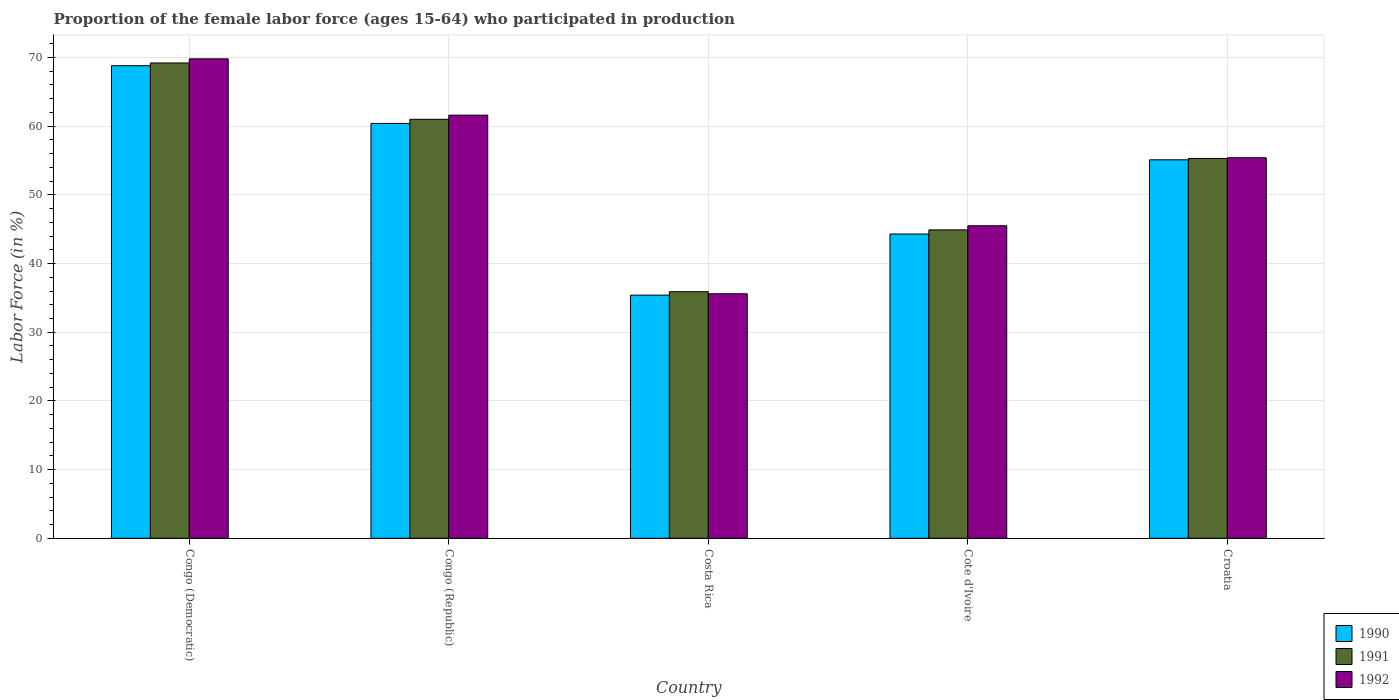How many different coloured bars are there?
Offer a terse response. 3. How many groups of bars are there?
Provide a succinct answer. 5. Are the number of bars on each tick of the X-axis equal?
Offer a very short reply. Yes. How many bars are there on the 3rd tick from the left?
Ensure brevity in your answer.  3. What is the label of the 3rd group of bars from the left?
Your answer should be compact. Costa Rica. In how many cases, is the number of bars for a given country not equal to the number of legend labels?
Your answer should be very brief. 0. What is the proportion of the female labor force who participated in production in 1991 in Costa Rica?
Offer a terse response. 35.9. Across all countries, what is the maximum proportion of the female labor force who participated in production in 1991?
Offer a very short reply. 69.2. Across all countries, what is the minimum proportion of the female labor force who participated in production in 1990?
Your answer should be compact. 35.4. In which country was the proportion of the female labor force who participated in production in 1992 maximum?
Make the answer very short. Congo (Democratic). In which country was the proportion of the female labor force who participated in production in 1991 minimum?
Ensure brevity in your answer.  Costa Rica. What is the total proportion of the female labor force who participated in production in 1992 in the graph?
Provide a succinct answer. 267.9. What is the difference between the proportion of the female labor force who participated in production in 1990 in Cote d'Ivoire and that in Croatia?
Give a very brief answer. -10.8. What is the average proportion of the female labor force who participated in production in 1992 per country?
Give a very brief answer. 53.58. What is the difference between the proportion of the female labor force who participated in production of/in 1991 and proportion of the female labor force who participated in production of/in 1990 in Croatia?
Give a very brief answer. 0.2. In how many countries, is the proportion of the female labor force who participated in production in 1990 greater than 62 %?
Your answer should be very brief. 1. What is the ratio of the proportion of the female labor force who participated in production in 1991 in Costa Rica to that in Cote d'Ivoire?
Your answer should be compact. 0.8. Is the proportion of the female labor force who participated in production in 1990 in Congo (Republic) less than that in Cote d'Ivoire?
Make the answer very short. No. Is the difference between the proportion of the female labor force who participated in production in 1991 in Costa Rica and Croatia greater than the difference between the proportion of the female labor force who participated in production in 1990 in Costa Rica and Croatia?
Keep it short and to the point. Yes. What is the difference between the highest and the second highest proportion of the female labor force who participated in production in 1990?
Your answer should be very brief. 8.4. What is the difference between the highest and the lowest proportion of the female labor force who participated in production in 1990?
Give a very brief answer. 33.4. In how many countries, is the proportion of the female labor force who participated in production in 1992 greater than the average proportion of the female labor force who participated in production in 1992 taken over all countries?
Provide a short and direct response. 3. Is the sum of the proportion of the female labor force who participated in production in 1990 in Congo (Republic) and Cote d'Ivoire greater than the maximum proportion of the female labor force who participated in production in 1991 across all countries?
Your response must be concise. Yes. What does the 2nd bar from the right in Congo (Republic) represents?
Make the answer very short. 1991. Is it the case that in every country, the sum of the proportion of the female labor force who participated in production in 1991 and proportion of the female labor force who participated in production in 1990 is greater than the proportion of the female labor force who participated in production in 1992?
Give a very brief answer. Yes. How many bars are there?
Provide a succinct answer. 15. How many countries are there in the graph?
Your answer should be very brief. 5. Are the values on the major ticks of Y-axis written in scientific E-notation?
Provide a short and direct response. No. Does the graph contain grids?
Offer a terse response. Yes. How many legend labels are there?
Your answer should be very brief. 3. What is the title of the graph?
Your answer should be very brief. Proportion of the female labor force (ages 15-64) who participated in production. Does "1997" appear as one of the legend labels in the graph?
Give a very brief answer. No. What is the label or title of the Y-axis?
Your answer should be compact. Labor Force (in %). What is the Labor Force (in %) in 1990 in Congo (Democratic)?
Provide a succinct answer. 68.8. What is the Labor Force (in %) of 1991 in Congo (Democratic)?
Your answer should be very brief. 69.2. What is the Labor Force (in %) of 1992 in Congo (Democratic)?
Offer a very short reply. 69.8. What is the Labor Force (in %) in 1990 in Congo (Republic)?
Make the answer very short. 60.4. What is the Labor Force (in %) of 1991 in Congo (Republic)?
Your answer should be very brief. 61. What is the Labor Force (in %) of 1992 in Congo (Republic)?
Give a very brief answer. 61.6. What is the Labor Force (in %) in 1990 in Costa Rica?
Provide a succinct answer. 35.4. What is the Labor Force (in %) in 1991 in Costa Rica?
Your answer should be compact. 35.9. What is the Labor Force (in %) of 1992 in Costa Rica?
Provide a succinct answer. 35.6. What is the Labor Force (in %) in 1990 in Cote d'Ivoire?
Your answer should be compact. 44.3. What is the Labor Force (in %) of 1991 in Cote d'Ivoire?
Keep it short and to the point. 44.9. What is the Labor Force (in %) in 1992 in Cote d'Ivoire?
Provide a succinct answer. 45.5. What is the Labor Force (in %) in 1990 in Croatia?
Give a very brief answer. 55.1. What is the Labor Force (in %) of 1991 in Croatia?
Offer a very short reply. 55.3. What is the Labor Force (in %) in 1992 in Croatia?
Give a very brief answer. 55.4. Across all countries, what is the maximum Labor Force (in %) in 1990?
Offer a terse response. 68.8. Across all countries, what is the maximum Labor Force (in %) of 1991?
Your response must be concise. 69.2. Across all countries, what is the maximum Labor Force (in %) in 1992?
Offer a very short reply. 69.8. Across all countries, what is the minimum Labor Force (in %) of 1990?
Your answer should be very brief. 35.4. Across all countries, what is the minimum Labor Force (in %) of 1991?
Provide a short and direct response. 35.9. Across all countries, what is the minimum Labor Force (in %) in 1992?
Offer a very short reply. 35.6. What is the total Labor Force (in %) of 1990 in the graph?
Offer a terse response. 264. What is the total Labor Force (in %) in 1991 in the graph?
Provide a short and direct response. 266.3. What is the total Labor Force (in %) of 1992 in the graph?
Keep it short and to the point. 267.9. What is the difference between the Labor Force (in %) in 1990 in Congo (Democratic) and that in Congo (Republic)?
Provide a succinct answer. 8.4. What is the difference between the Labor Force (in %) in 1990 in Congo (Democratic) and that in Costa Rica?
Your response must be concise. 33.4. What is the difference between the Labor Force (in %) of 1991 in Congo (Democratic) and that in Costa Rica?
Your response must be concise. 33.3. What is the difference between the Labor Force (in %) in 1992 in Congo (Democratic) and that in Costa Rica?
Your response must be concise. 34.2. What is the difference between the Labor Force (in %) of 1990 in Congo (Democratic) and that in Cote d'Ivoire?
Offer a terse response. 24.5. What is the difference between the Labor Force (in %) of 1991 in Congo (Democratic) and that in Cote d'Ivoire?
Your answer should be compact. 24.3. What is the difference between the Labor Force (in %) in 1992 in Congo (Democratic) and that in Cote d'Ivoire?
Give a very brief answer. 24.3. What is the difference between the Labor Force (in %) in 1990 in Congo (Democratic) and that in Croatia?
Your answer should be compact. 13.7. What is the difference between the Labor Force (in %) in 1991 in Congo (Democratic) and that in Croatia?
Offer a terse response. 13.9. What is the difference between the Labor Force (in %) of 1992 in Congo (Democratic) and that in Croatia?
Offer a very short reply. 14.4. What is the difference between the Labor Force (in %) in 1990 in Congo (Republic) and that in Costa Rica?
Ensure brevity in your answer.  25. What is the difference between the Labor Force (in %) of 1991 in Congo (Republic) and that in Costa Rica?
Keep it short and to the point. 25.1. What is the difference between the Labor Force (in %) of 1992 in Congo (Republic) and that in Costa Rica?
Offer a very short reply. 26. What is the difference between the Labor Force (in %) of 1990 in Congo (Republic) and that in Cote d'Ivoire?
Your answer should be compact. 16.1. What is the difference between the Labor Force (in %) of 1991 in Congo (Republic) and that in Cote d'Ivoire?
Give a very brief answer. 16.1. What is the difference between the Labor Force (in %) in 1990 in Congo (Republic) and that in Croatia?
Give a very brief answer. 5.3. What is the difference between the Labor Force (in %) of 1992 in Congo (Republic) and that in Croatia?
Provide a succinct answer. 6.2. What is the difference between the Labor Force (in %) in 1990 in Costa Rica and that in Croatia?
Your answer should be compact. -19.7. What is the difference between the Labor Force (in %) in 1991 in Costa Rica and that in Croatia?
Ensure brevity in your answer.  -19.4. What is the difference between the Labor Force (in %) of 1992 in Costa Rica and that in Croatia?
Provide a succinct answer. -19.8. What is the difference between the Labor Force (in %) of 1992 in Cote d'Ivoire and that in Croatia?
Ensure brevity in your answer.  -9.9. What is the difference between the Labor Force (in %) of 1990 in Congo (Democratic) and the Labor Force (in %) of 1992 in Congo (Republic)?
Ensure brevity in your answer.  7.2. What is the difference between the Labor Force (in %) of 1990 in Congo (Democratic) and the Labor Force (in %) of 1991 in Costa Rica?
Keep it short and to the point. 32.9. What is the difference between the Labor Force (in %) in 1990 in Congo (Democratic) and the Labor Force (in %) in 1992 in Costa Rica?
Provide a short and direct response. 33.2. What is the difference between the Labor Force (in %) in 1991 in Congo (Democratic) and the Labor Force (in %) in 1992 in Costa Rica?
Provide a succinct answer. 33.6. What is the difference between the Labor Force (in %) in 1990 in Congo (Democratic) and the Labor Force (in %) in 1991 in Cote d'Ivoire?
Provide a short and direct response. 23.9. What is the difference between the Labor Force (in %) in 1990 in Congo (Democratic) and the Labor Force (in %) in 1992 in Cote d'Ivoire?
Your response must be concise. 23.3. What is the difference between the Labor Force (in %) of 1991 in Congo (Democratic) and the Labor Force (in %) of 1992 in Cote d'Ivoire?
Your answer should be compact. 23.7. What is the difference between the Labor Force (in %) in 1990 in Congo (Democratic) and the Labor Force (in %) in 1991 in Croatia?
Give a very brief answer. 13.5. What is the difference between the Labor Force (in %) in 1990 in Congo (Democratic) and the Labor Force (in %) in 1992 in Croatia?
Make the answer very short. 13.4. What is the difference between the Labor Force (in %) in 1990 in Congo (Republic) and the Labor Force (in %) in 1992 in Costa Rica?
Give a very brief answer. 24.8. What is the difference between the Labor Force (in %) in 1991 in Congo (Republic) and the Labor Force (in %) in 1992 in Costa Rica?
Your answer should be compact. 25.4. What is the difference between the Labor Force (in %) of 1990 in Congo (Republic) and the Labor Force (in %) of 1991 in Croatia?
Provide a succinct answer. 5.1. What is the difference between the Labor Force (in %) of 1990 in Congo (Republic) and the Labor Force (in %) of 1992 in Croatia?
Keep it short and to the point. 5. What is the difference between the Labor Force (in %) of 1991 in Congo (Republic) and the Labor Force (in %) of 1992 in Croatia?
Your answer should be very brief. 5.6. What is the difference between the Labor Force (in %) in 1990 in Costa Rica and the Labor Force (in %) in 1991 in Cote d'Ivoire?
Your response must be concise. -9.5. What is the difference between the Labor Force (in %) in 1990 in Costa Rica and the Labor Force (in %) in 1991 in Croatia?
Provide a succinct answer. -19.9. What is the difference between the Labor Force (in %) in 1991 in Costa Rica and the Labor Force (in %) in 1992 in Croatia?
Your answer should be compact. -19.5. What is the difference between the Labor Force (in %) of 1990 in Cote d'Ivoire and the Labor Force (in %) of 1992 in Croatia?
Give a very brief answer. -11.1. What is the difference between the Labor Force (in %) of 1991 in Cote d'Ivoire and the Labor Force (in %) of 1992 in Croatia?
Your response must be concise. -10.5. What is the average Labor Force (in %) in 1990 per country?
Ensure brevity in your answer.  52.8. What is the average Labor Force (in %) of 1991 per country?
Make the answer very short. 53.26. What is the average Labor Force (in %) in 1992 per country?
Provide a succinct answer. 53.58. What is the difference between the Labor Force (in %) of 1990 and Labor Force (in %) of 1991 in Congo (Republic)?
Your response must be concise. -0.6. What is the difference between the Labor Force (in %) of 1991 and Labor Force (in %) of 1992 in Congo (Republic)?
Provide a succinct answer. -0.6. What is the difference between the Labor Force (in %) of 1990 and Labor Force (in %) of 1991 in Costa Rica?
Your answer should be compact. -0.5. What is the difference between the Labor Force (in %) of 1990 and Labor Force (in %) of 1991 in Cote d'Ivoire?
Make the answer very short. -0.6. What is the difference between the Labor Force (in %) of 1990 and Labor Force (in %) of 1992 in Cote d'Ivoire?
Your answer should be very brief. -1.2. What is the difference between the Labor Force (in %) of 1991 and Labor Force (in %) of 1992 in Cote d'Ivoire?
Provide a succinct answer. -0.6. What is the difference between the Labor Force (in %) in 1990 and Labor Force (in %) in 1991 in Croatia?
Your answer should be compact. -0.2. What is the difference between the Labor Force (in %) of 1990 and Labor Force (in %) of 1992 in Croatia?
Ensure brevity in your answer.  -0.3. What is the difference between the Labor Force (in %) in 1991 and Labor Force (in %) in 1992 in Croatia?
Your answer should be very brief. -0.1. What is the ratio of the Labor Force (in %) of 1990 in Congo (Democratic) to that in Congo (Republic)?
Offer a very short reply. 1.14. What is the ratio of the Labor Force (in %) of 1991 in Congo (Democratic) to that in Congo (Republic)?
Provide a succinct answer. 1.13. What is the ratio of the Labor Force (in %) in 1992 in Congo (Democratic) to that in Congo (Republic)?
Your answer should be compact. 1.13. What is the ratio of the Labor Force (in %) of 1990 in Congo (Democratic) to that in Costa Rica?
Your answer should be compact. 1.94. What is the ratio of the Labor Force (in %) of 1991 in Congo (Democratic) to that in Costa Rica?
Your answer should be very brief. 1.93. What is the ratio of the Labor Force (in %) in 1992 in Congo (Democratic) to that in Costa Rica?
Keep it short and to the point. 1.96. What is the ratio of the Labor Force (in %) of 1990 in Congo (Democratic) to that in Cote d'Ivoire?
Offer a very short reply. 1.55. What is the ratio of the Labor Force (in %) in 1991 in Congo (Democratic) to that in Cote d'Ivoire?
Offer a terse response. 1.54. What is the ratio of the Labor Force (in %) of 1992 in Congo (Democratic) to that in Cote d'Ivoire?
Give a very brief answer. 1.53. What is the ratio of the Labor Force (in %) in 1990 in Congo (Democratic) to that in Croatia?
Your response must be concise. 1.25. What is the ratio of the Labor Force (in %) in 1991 in Congo (Democratic) to that in Croatia?
Give a very brief answer. 1.25. What is the ratio of the Labor Force (in %) of 1992 in Congo (Democratic) to that in Croatia?
Offer a terse response. 1.26. What is the ratio of the Labor Force (in %) in 1990 in Congo (Republic) to that in Costa Rica?
Offer a very short reply. 1.71. What is the ratio of the Labor Force (in %) in 1991 in Congo (Republic) to that in Costa Rica?
Keep it short and to the point. 1.7. What is the ratio of the Labor Force (in %) of 1992 in Congo (Republic) to that in Costa Rica?
Give a very brief answer. 1.73. What is the ratio of the Labor Force (in %) of 1990 in Congo (Republic) to that in Cote d'Ivoire?
Your response must be concise. 1.36. What is the ratio of the Labor Force (in %) in 1991 in Congo (Republic) to that in Cote d'Ivoire?
Your answer should be very brief. 1.36. What is the ratio of the Labor Force (in %) of 1992 in Congo (Republic) to that in Cote d'Ivoire?
Your response must be concise. 1.35. What is the ratio of the Labor Force (in %) of 1990 in Congo (Republic) to that in Croatia?
Keep it short and to the point. 1.1. What is the ratio of the Labor Force (in %) in 1991 in Congo (Republic) to that in Croatia?
Give a very brief answer. 1.1. What is the ratio of the Labor Force (in %) in 1992 in Congo (Republic) to that in Croatia?
Offer a very short reply. 1.11. What is the ratio of the Labor Force (in %) of 1990 in Costa Rica to that in Cote d'Ivoire?
Offer a very short reply. 0.8. What is the ratio of the Labor Force (in %) of 1991 in Costa Rica to that in Cote d'Ivoire?
Ensure brevity in your answer.  0.8. What is the ratio of the Labor Force (in %) in 1992 in Costa Rica to that in Cote d'Ivoire?
Your answer should be very brief. 0.78. What is the ratio of the Labor Force (in %) of 1990 in Costa Rica to that in Croatia?
Offer a terse response. 0.64. What is the ratio of the Labor Force (in %) in 1991 in Costa Rica to that in Croatia?
Your answer should be very brief. 0.65. What is the ratio of the Labor Force (in %) of 1992 in Costa Rica to that in Croatia?
Your answer should be very brief. 0.64. What is the ratio of the Labor Force (in %) in 1990 in Cote d'Ivoire to that in Croatia?
Your response must be concise. 0.8. What is the ratio of the Labor Force (in %) in 1991 in Cote d'Ivoire to that in Croatia?
Offer a terse response. 0.81. What is the ratio of the Labor Force (in %) in 1992 in Cote d'Ivoire to that in Croatia?
Offer a very short reply. 0.82. What is the difference between the highest and the second highest Labor Force (in %) of 1990?
Your answer should be very brief. 8.4. What is the difference between the highest and the second highest Labor Force (in %) of 1992?
Provide a short and direct response. 8.2. What is the difference between the highest and the lowest Labor Force (in %) in 1990?
Offer a very short reply. 33.4. What is the difference between the highest and the lowest Labor Force (in %) in 1991?
Offer a terse response. 33.3. What is the difference between the highest and the lowest Labor Force (in %) in 1992?
Keep it short and to the point. 34.2. 